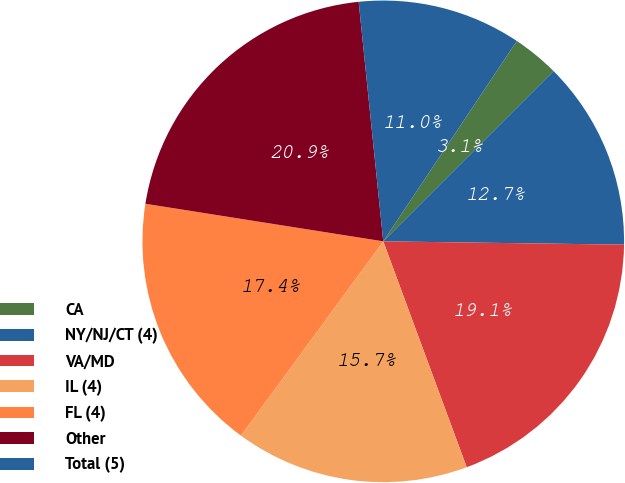<chart> <loc_0><loc_0><loc_500><loc_500><pie_chart><fcel>CA<fcel>NY/NJ/CT (4)<fcel>VA/MD<fcel>IL (4)<fcel>FL (4)<fcel>Other<fcel>Total (5)<nl><fcel>3.14%<fcel>12.72%<fcel>19.15%<fcel>15.7%<fcel>17.43%<fcel>20.88%<fcel>10.99%<nl></chart> 